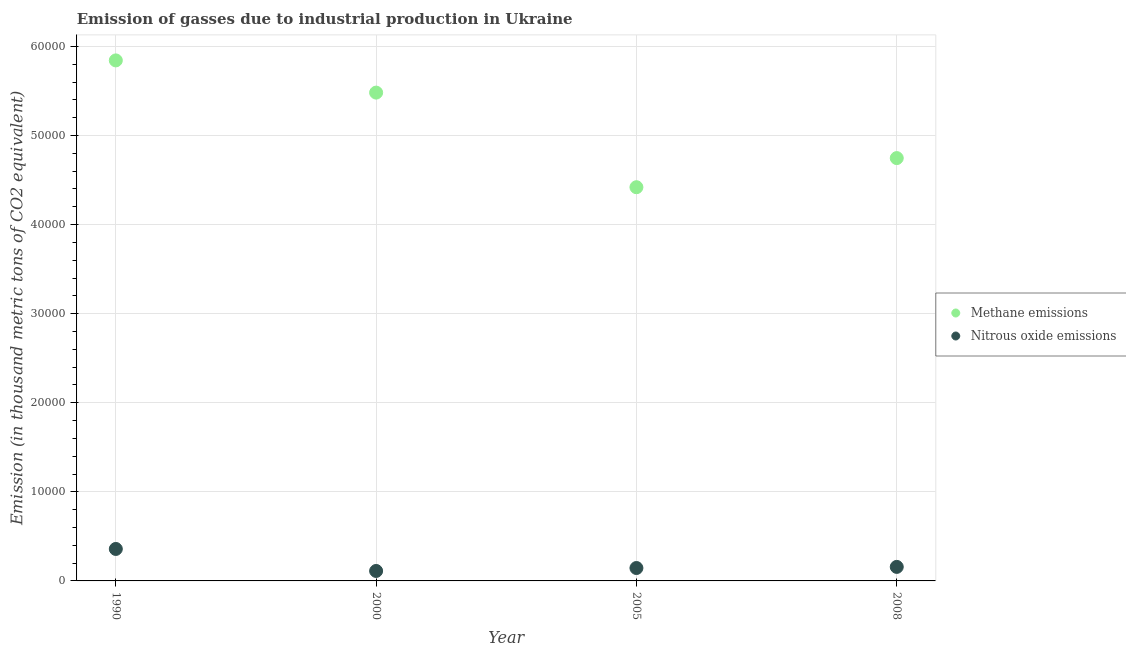What is the amount of methane emissions in 2000?
Ensure brevity in your answer.  5.48e+04. Across all years, what is the maximum amount of nitrous oxide emissions?
Your response must be concise. 3588.3. Across all years, what is the minimum amount of nitrous oxide emissions?
Your answer should be very brief. 1117.9. In which year was the amount of methane emissions minimum?
Make the answer very short. 2005. What is the total amount of methane emissions in the graph?
Make the answer very short. 2.05e+05. What is the difference between the amount of nitrous oxide emissions in 2005 and that in 2008?
Your answer should be compact. -126.2. What is the difference between the amount of nitrous oxide emissions in 2000 and the amount of methane emissions in 2005?
Keep it short and to the point. -4.31e+04. What is the average amount of methane emissions per year?
Keep it short and to the point. 5.12e+04. In the year 2008, what is the difference between the amount of methane emissions and amount of nitrous oxide emissions?
Your response must be concise. 4.59e+04. What is the ratio of the amount of nitrous oxide emissions in 1990 to that in 2000?
Offer a very short reply. 3.21. Is the amount of nitrous oxide emissions in 1990 less than that in 2000?
Keep it short and to the point. No. What is the difference between the highest and the second highest amount of methane emissions?
Provide a succinct answer. 3615.2. What is the difference between the highest and the lowest amount of nitrous oxide emissions?
Offer a very short reply. 2470.4. Is the sum of the amount of nitrous oxide emissions in 1990 and 2005 greater than the maximum amount of methane emissions across all years?
Give a very brief answer. No. Does the amount of nitrous oxide emissions monotonically increase over the years?
Provide a short and direct response. No. Is the amount of methane emissions strictly less than the amount of nitrous oxide emissions over the years?
Ensure brevity in your answer.  No. What is the difference between two consecutive major ticks on the Y-axis?
Your answer should be compact. 10000. Does the graph contain grids?
Make the answer very short. Yes. Where does the legend appear in the graph?
Your response must be concise. Center right. How are the legend labels stacked?
Provide a short and direct response. Vertical. What is the title of the graph?
Your answer should be very brief. Emission of gasses due to industrial production in Ukraine. What is the label or title of the Y-axis?
Offer a terse response. Emission (in thousand metric tons of CO2 equivalent). What is the Emission (in thousand metric tons of CO2 equivalent) of Methane emissions in 1990?
Offer a terse response. 5.84e+04. What is the Emission (in thousand metric tons of CO2 equivalent) in Nitrous oxide emissions in 1990?
Provide a succinct answer. 3588.3. What is the Emission (in thousand metric tons of CO2 equivalent) in Methane emissions in 2000?
Provide a short and direct response. 5.48e+04. What is the Emission (in thousand metric tons of CO2 equivalent) of Nitrous oxide emissions in 2000?
Your response must be concise. 1117.9. What is the Emission (in thousand metric tons of CO2 equivalent) in Methane emissions in 2005?
Your response must be concise. 4.42e+04. What is the Emission (in thousand metric tons of CO2 equivalent) of Nitrous oxide emissions in 2005?
Your response must be concise. 1448.5. What is the Emission (in thousand metric tons of CO2 equivalent) of Methane emissions in 2008?
Ensure brevity in your answer.  4.75e+04. What is the Emission (in thousand metric tons of CO2 equivalent) of Nitrous oxide emissions in 2008?
Provide a succinct answer. 1574.7. Across all years, what is the maximum Emission (in thousand metric tons of CO2 equivalent) in Methane emissions?
Your response must be concise. 5.84e+04. Across all years, what is the maximum Emission (in thousand metric tons of CO2 equivalent) in Nitrous oxide emissions?
Your response must be concise. 3588.3. Across all years, what is the minimum Emission (in thousand metric tons of CO2 equivalent) in Methane emissions?
Your answer should be compact. 4.42e+04. Across all years, what is the minimum Emission (in thousand metric tons of CO2 equivalent) of Nitrous oxide emissions?
Keep it short and to the point. 1117.9. What is the total Emission (in thousand metric tons of CO2 equivalent) of Methane emissions in the graph?
Provide a short and direct response. 2.05e+05. What is the total Emission (in thousand metric tons of CO2 equivalent) in Nitrous oxide emissions in the graph?
Offer a very short reply. 7729.4. What is the difference between the Emission (in thousand metric tons of CO2 equivalent) of Methane emissions in 1990 and that in 2000?
Offer a terse response. 3615.2. What is the difference between the Emission (in thousand metric tons of CO2 equivalent) in Nitrous oxide emissions in 1990 and that in 2000?
Your answer should be very brief. 2470.4. What is the difference between the Emission (in thousand metric tons of CO2 equivalent) in Methane emissions in 1990 and that in 2005?
Ensure brevity in your answer.  1.42e+04. What is the difference between the Emission (in thousand metric tons of CO2 equivalent) of Nitrous oxide emissions in 1990 and that in 2005?
Make the answer very short. 2139.8. What is the difference between the Emission (in thousand metric tons of CO2 equivalent) of Methane emissions in 1990 and that in 2008?
Your answer should be compact. 1.10e+04. What is the difference between the Emission (in thousand metric tons of CO2 equivalent) of Nitrous oxide emissions in 1990 and that in 2008?
Provide a short and direct response. 2013.6. What is the difference between the Emission (in thousand metric tons of CO2 equivalent) of Methane emissions in 2000 and that in 2005?
Provide a succinct answer. 1.06e+04. What is the difference between the Emission (in thousand metric tons of CO2 equivalent) in Nitrous oxide emissions in 2000 and that in 2005?
Offer a terse response. -330.6. What is the difference between the Emission (in thousand metric tons of CO2 equivalent) in Methane emissions in 2000 and that in 2008?
Ensure brevity in your answer.  7351.3. What is the difference between the Emission (in thousand metric tons of CO2 equivalent) in Nitrous oxide emissions in 2000 and that in 2008?
Your answer should be very brief. -456.8. What is the difference between the Emission (in thousand metric tons of CO2 equivalent) of Methane emissions in 2005 and that in 2008?
Keep it short and to the point. -3269.3. What is the difference between the Emission (in thousand metric tons of CO2 equivalent) of Nitrous oxide emissions in 2005 and that in 2008?
Your answer should be very brief. -126.2. What is the difference between the Emission (in thousand metric tons of CO2 equivalent) of Methane emissions in 1990 and the Emission (in thousand metric tons of CO2 equivalent) of Nitrous oxide emissions in 2000?
Ensure brevity in your answer.  5.73e+04. What is the difference between the Emission (in thousand metric tons of CO2 equivalent) of Methane emissions in 1990 and the Emission (in thousand metric tons of CO2 equivalent) of Nitrous oxide emissions in 2005?
Ensure brevity in your answer.  5.70e+04. What is the difference between the Emission (in thousand metric tons of CO2 equivalent) in Methane emissions in 1990 and the Emission (in thousand metric tons of CO2 equivalent) in Nitrous oxide emissions in 2008?
Provide a short and direct response. 5.69e+04. What is the difference between the Emission (in thousand metric tons of CO2 equivalent) of Methane emissions in 2000 and the Emission (in thousand metric tons of CO2 equivalent) of Nitrous oxide emissions in 2005?
Keep it short and to the point. 5.34e+04. What is the difference between the Emission (in thousand metric tons of CO2 equivalent) of Methane emissions in 2000 and the Emission (in thousand metric tons of CO2 equivalent) of Nitrous oxide emissions in 2008?
Your answer should be compact. 5.32e+04. What is the difference between the Emission (in thousand metric tons of CO2 equivalent) of Methane emissions in 2005 and the Emission (in thousand metric tons of CO2 equivalent) of Nitrous oxide emissions in 2008?
Provide a short and direct response. 4.26e+04. What is the average Emission (in thousand metric tons of CO2 equivalent) in Methane emissions per year?
Provide a succinct answer. 5.12e+04. What is the average Emission (in thousand metric tons of CO2 equivalent) of Nitrous oxide emissions per year?
Offer a terse response. 1932.35. In the year 1990, what is the difference between the Emission (in thousand metric tons of CO2 equivalent) of Methane emissions and Emission (in thousand metric tons of CO2 equivalent) of Nitrous oxide emissions?
Offer a very short reply. 5.48e+04. In the year 2000, what is the difference between the Emission (in thousand metric tons of CO2 equivalent) of Methane emissions and Emission (in thousand metric tons of CO2 equivalent) of Nitrous oxide emissions?
Your answer should be compact. 5.37e+04. In the year 2005, what is the difference between the Emission (in thousand metric tons of CO2 equivalent) of Methane emissions and Emission (in thousand metric tons of CO2 equivalent) of Nitrous oxide emissions?
Ensure brevity in your answer.  4.28e+04. In the year 2008, what is the difference between the Emission (in thousand metric tons of CO2 equivalent) in Methane emissions and Emission (in thousand metric tons of CO2 equivalent) in Nitrous oxide emissions?
Your answer should be very brief. 4.59e+04. What is the ratio of the Emission (in thousand metric tons of CO2 equivalent) of Methane emissions in 1990 to that in 2000?
Provide a succinct answer. 1.07. What is the ratio of the Emission (in thousand metric tons of CO2 equivalent) of Nitrous oxide emissions in 1990 to that in 2000?
Your response must be concise. 3.21. What is the ratio of the Emission (in thousand metric tons of CO2 equivalent) in Methane emissions in 1990 to that in 2005?
Your answer should be compact. 1.32. What is the ratio of the Emission (in thousand metric tons of CO2 equivalent) of Nitrous oxide emissions in 1990 to that in 2005?
Provide a succinct answer. 2.48. What is the ratio of the Emission (in thousand metric tons of CO2 equivalent) in Methane emissions in 1990 to that in 2008?
Offer a terse response. 1.23. What is the ratio of the Emission (in thousand metric tons of CO2 equivalent) in Nitrous oxide emissions in 1990 to that in 2008?
Your answer should be very brief. 2.28. What is the ratio of the Emission (in thousand metric tons of CO2 equivalent) of Methane emissions in 2000 to that in 2005?
Your response must be concise. 1.24. What is the ratio of the Emission (in thousand metric tons of CO2 equivalent) in Nitrous oxide emissions in 2000 to that in 2005?
Keep it short and to the point. 0.77. What is the ratio of the Emission (in thousand metric tons of CO2 equivalent) in Methane emissions in 2000 to that in 2008?
Give a very brief answer. 1.15. What is the ratio of the Emission (in thousand metric tons of CO2 equivalent) of Nitrous oxide emissions in 2000 to that in 2008?
Offer a terse response. 0.71. What is the ratio of the Emission (in thousand metric tons of CO2 equivalent) of Methane emissions in 2005 to that in 2008?
Make the answer very short. 0.93. What is the ratio of the Emission (in thousand metric tons of CO2 equivalent) of Nitrous oxide emissions in 2005 to that in 2008?
Give a very brief answer. 0.92. What is the difference between the highest and the second highest Emission (in thousand metric tons of CO2 equivalent) in Methane emissions?
Your answer should be very brief. 3615.2. What is the difference between the highest and the second highest Emission (in thousand metric tons of CO2 equivalent) of Nitrous oxide emissions?
Give a very brief answer. 2013.6. What is the difference between the highest and the lowest Emission (in thousand metric tons of CO2 equivalent) in Methane emissions?
Your answer should be very brief. 1.42e+04. What is the difference between the highest and the lowest Emission (in thousand metric tons of CO2 equivalent) of Nitrous oxide emissions?
Provide a succinct answer. 2470.4. 